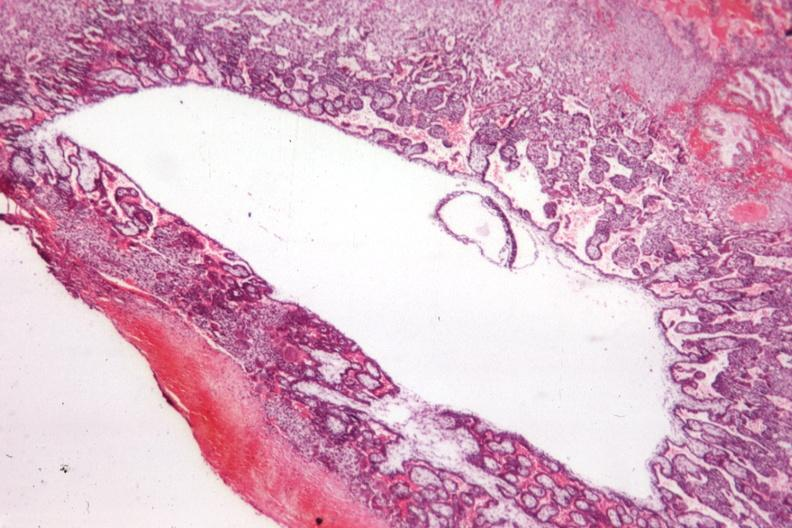s liver present?
Answer the question using a single word or phrase. No 